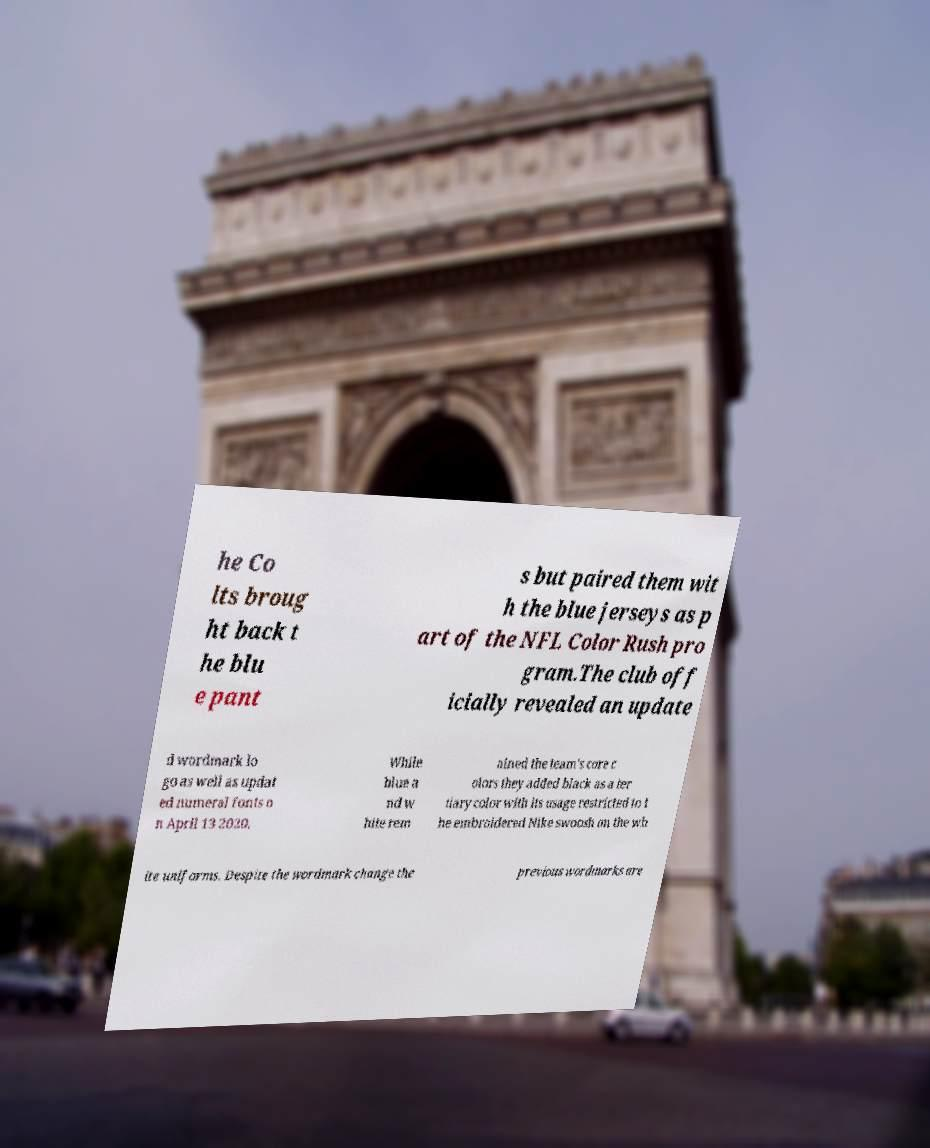For documentation purposes, I need the text within this image transcribed. Could you provide that? he Co lts broug ht back t he blu e pant s but paired them wit h the blue jerseys as p art of the NFL Color Rush pro gram.The club off icially revealed an update d wordmark lo go as well as updat ed numeral fonts o n April 13 2020. While blue a nd w hite rem ained the team's core c olors they added black as a ter tiary color with its usage restricted to t he embroidered Nike swoosh on the wh ite uniforms. Despite the wordmark change the previous wordmarks are 